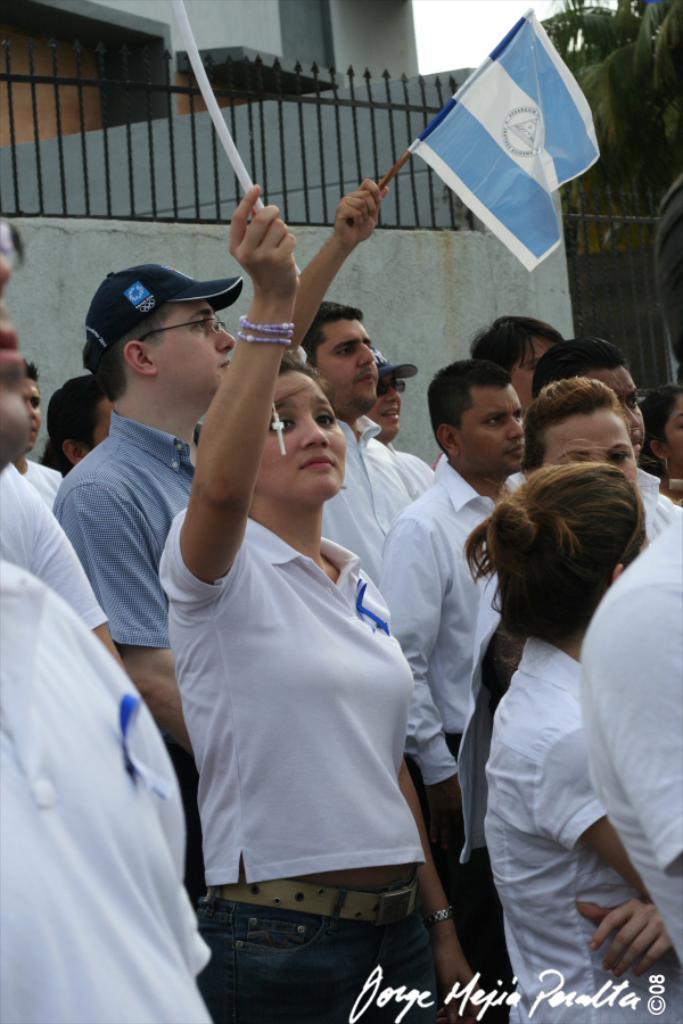Could you give a brief overview of what you see in this image? In the center of the image we can see woman standing with the flag. ON the right side of the image we can see a group of persons. In the background there is a wall, fencing, building, tree and sky. 